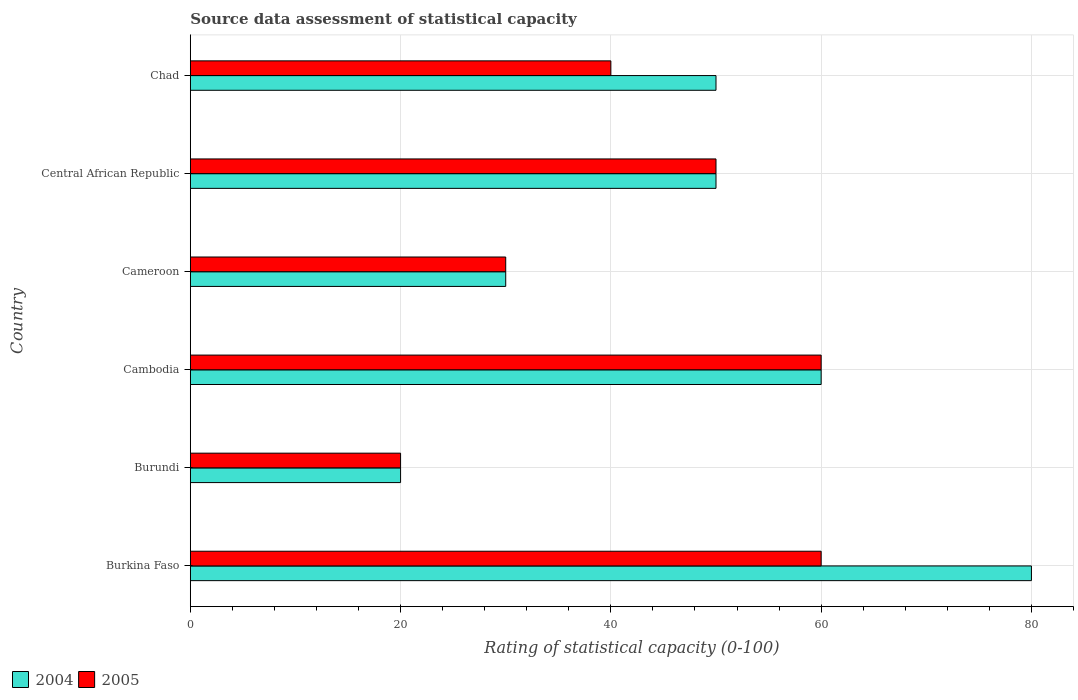How many groups of bars are there?
Your answer should be very brief. 6. Are the number of bars on each tick of the Y-axis equal?
Your answer should be compact. Yes. How many bars are there on the 2nd tick from the top?
Give a very brief answer. 2. How many bars are there on the 1st tick from the bottom?
Ensure brevity in your answer.  2. What is the label of the 3rd group of bars from the top?
Your answer should be very brief. Cameroon. In how many cases, is the number of bars for a given country not equal to the number of legend labels?
Keep it short and to the point. 0. What is the rating of statistical capacity in 2004 in Burkina Faso?
Keep it short and to the point. 80. Across all countries, what is the minimum rating of statistical capacity in 2005?
Offer a terse response. 20. In which country was the rating of statistical capacity in 2005 maximum?
Your answer should be very brief. Burkina Faso. In which country was the rating of statistical capacity in 2004 minimum?
Offer a very short reply. Burundi. What is the total rating of statistical capacity in 2005 in the graph?
Give a very brief answer. 260. What is the difference between the rating of statistical capacity in 2004 in Burkina Faso and that in Cambodia?
Provide a short and direct response. 20. What is the difference between the rating of statistical capacity in 2005 in Burundi and the rating of statistical capacity in 2004 in Burkina Faso?
Your answer should be compact. -60. What is the average rating of statistical capacity in 2004 per country?
Provide a short and direct response. 48.33. What is the difference between the rating of statistical capacity in 2004 and rating of statistical capacity in 2005 in Burkina Faso?
Provide a succinct answer. 20. In how many countries, is the rating of statistical capacity in 2005 greater than 40 ?
Provide a short and direct response. 3. What is the ratio of the rating of statistical capacity in 2005 in Burkina Faso to that in Cambodia?
Make the answer very short. 1. Is the rating of statistical capacity in 2004 in Burkina Faso less than that in Cameroon?
Give a very brief answer. No. Is the difference between the rating of statistical capacity in 2004 in Cameroon and Chad greater than the difference between the rating of statistical capacity in 2005 in Cameroon and Chad?
Your answer should be compact. No. What is the difference between the highest and the lowest rating of statistical capacity in 2005?
Your answer should be compact. 40. In how many countries, is the rating of statistical capacity in 2004 greater than the average rating of statistical capacity in 2004 taken over all countries?
Offer a terse response. 4. What does the 1st bar from the bottom in Chad represents?
Provide a short and direct response. 2004. How many countries are there in the graph?
Offer a terse response. 6. What is the difference between two consecutive major ticks on the X-axis?
Keep it short and to the point. 20. Are the values on the major ticks of X-axis written in scientific E-notation?
Offer a very short reply. No. Does the graph contain any zero values?
Offer a terse response. No. Does the graph contain grids?
Offer a very short reply. Yes. How are the legend labels stacked?
Keep it short and to the point. Horizontal. What is the title of the graph?
Your answer should be very brief. Source data assessment of statistical capacity. What is the label or title of the X-axis?
Ensure brevity in your answer.  Rating of statistical capacity (0-100). What is the Rating of statistical capacity (0-100) of 2004 in Burkina Faso?
Give a very brief answer. 80. What is the Rating of statistical capacity (0-100) of 2005 in Burkina Faso?
Your answer should be very brief. 60. What is the Rating of statistical capacity (0-100) in 2004 in Cameroon?
Provide a short and direct response. 30. What is the Rating of statistical capacity (0-100) of 2005 in Cameroon?
Provide a short and direct response. 30. What is the Rating of statistical capacity (0-100) of 2004 in Central African Republic?
Offer a very short reply. 50. What is the Rating of statistical capacity (0-100) of 2004 in Chad?
Give a very brief answer. 50. Across all countries, what is the maximum Rating of statistical capacity (0-100) in 2004?
Your answer should be very brief. 80. Across all countries, what is the minimum Rating of statistical capacity (0-100) in 2004?
Ensure brevity in your answer.  20. Across all countries, what is the minimum Rating of statistical capacity (0-100) of 2005?
Your answer should be compact. 20. What is the total Rating of statistical capacity (0-100) in 2004 in the graph?
Make the answer very short. 290. What is the total Rating of statistical capacity (0-100) of 2005 in the graph?
Provide a succinct answer. 260. What is the difference between the Rating of statistical capacity (0-100) in 2005 in Burkina Faso and that in Cameroon?
Offer a terse response. 30. What is the difference between the Rating of statistical capacity (0-100) of 2004 in Burkina Faso and that in Central African Republic?
Provide a succinct answer. 30. What is the difference between the Rating of statistical capacity (0-100) of 2005 in Burkina Faso and that in Central African Republic?
Give a very brief answer. 10. What is the difference between the Rating of statistical capacity (0-100) in 2004 in Burundi and that in Cameroon?
Provide a short and direct response. -10. What is the difference between the Rating of statistical capacity (0-100) of 2004 in Burundi and that in Chad?
Keep it short and to the point. -30. What is the difference between the Rating of statistical capacity (0-100) in 2004 in Cambodia and that in Central African Republic?
Your response must be concise. 10. What is the difference between the Rating of statistical capacity (0-100) in 2005 in Cambodia and that in Chad?
Ensure brevity in your answer.  20. What is the difference between the Rating of statistical capacity (0-100) of 2005 in Cameroon and that in Central African Republic?
Make the answer very short. -20. What is the difference between the Rating of statistical capacity (0-100) of 2004 in Central African Republic and that in Chad?
Give a very brief answer. 0. What is the difference between the Rating of statistical capacity (0-100) of 2005 in Central African Republic and that in Chad?
Your answer should be compact. 10. What is the difference between the Rating of statistical capacity (0-100) in 2004 in Burkina Faso and the Rating of statistical capacity (0-100) in 2005 in Cambodia?
Make the answer very short. 20. What is the difference between the Rating of statistical capacity (0-100) of 2004 in Burkina Faso and the Rating of statistical capacity (0-100) of 2005 in Cameroon?
Your response must be concise. 50. What is the difference between the Rating of statistical capacity (0-100) of 2004 in Burkina Faso and the Rating of statistical capacity (0-100) of 2005 in Chad?
Your answer should be compact. 40. What is the difference between the Rating of statistical capacity (0-100) in 2004 in Burundi and the Rating of statistical capacity (0-100) in 2005 in Chad?
Offer a very short reply. -20. What is the difference between the Rating of statistical capacity (0-100) in 2004 in Cambodia and the Rating of statistical capacity (0-100) in 2005 in Central African Republic?
Your answer should be compact. 10. What is the difference between the Rating of statistical capacity (0-100) of 2004 in Cameroon and the Rating of statistical capacity (0-100) of 2005 in Central African Republic?
Your response must be concise. -20. What is the difference between the Rating of statistical capacity (0-100) in 2004 in Central African Republic and the Rating of statistical capacity (0-100) in 2005 in Chad?
Make the answer very short. 10. What is the average Rating of statistical capacity (0-100) of 2004 per country?
Your answer should be very brief. 48.33. What is the average Rating of statistical capacity (0-100) of 2005 per country?
Offer a terse response. 43.33. What is the difference between the Rating of statistical capacity (0-100) of 2004 and Rating of statistical capacity (0-100) of 2005 in Burkina Faso?
Provide a short and direct response. 20. What is the difference between the Rating of statistical capacity (0-100) in 2004 and Rating of statistical capacity (0-100) in 2005 in Cameroon?
Offer a terse response. 0. What is the difference between the Rating of statistical capacity (0-100) of 2004 and Rating of statistical capacity (0-100) of 2005 in Chad?
Your answer should be very brief. 10. What is the ratio of the Rating of statistical capacity (0-100) of 2004 in Burkina Faso to that in Burundi?
Your answer should be compact. 4. What is the ratio of the Rating of statistical capacity (0-100) of 2005 in Burkina Faso to that in Burundi?
Provide a short and direct response. 3. What is the ratio of the Rating of statistical capacity (0-100) in 2004 in Burkina Faso to that in Cambodia?
Make the answer very short. 1.33. What is the ratio of the Rating of statistical capacity (0-100) in 2004 in Burkina Faso to that in Cameroon?
Ensure brevity in your answer.  2.67. What is the ratio of the Rating of statistical capacity (0-100) of 2005 in Burkina Faso to that in Chad?
Make the answer very short. 1.5. What is the ratio of the Rating of statistical capacity (0-100) in 2004 in Burundi to that in Cameroon?
Provide a short and direct response. 0.67. What is the ratio of the Rating of statistical capacity (0-100) in 2004 in Burundi to that in Central African Republic?
Provide a short and direct response. 0.4. What is the ratio of the Rating of statistical capacity (0-100) of 2005 in Burundi to that in Chad?
Make the answer very short. 0.5. What is the ratio of the Rating of statistical capacity (0-100) in 2004 in Cambodia to that in Cameroon?
Ensure brevity in your answer.  2. What is the ratio of the Rating of statistical capacity (0-100) of 2005 in Cambodia to that in Cameroon?
Keep it short and to the point. 2. What is the ratio of the Rating of statistical capacity (0-100) in 2004 in Cambodia to that in Chad?
Your answer should be very brief. 1.2. What is the ratio of the Rating of statistical capacity (0-100) in 2005 in Cambodia to that in Chad?
Your answer should be compact. 1.5. What is the ratio of the Rating of statistical capacity (0-100) of 2005 in Cameroon to that in Central African Republic?
Give a very brief answer. 0.6. What is the ratio of the Rating of statistical capacity (0-100) of 2004 in Cameroon to that in Chad?
Your answer should be very brief. 0.6. What is the ratio of the Rating of statistical capacity (0-100) in 2005 in Cameroon to that in Chad?
Make the answer very short. 0.75. What is the ratio of the Rating of statistical capacity (0-100) in 2004 in Central African Republic to that in Chad?
Provide a succinct answer. 1. What is the ratio of the Rating of statistical capacity (0-100) of 2005 in Central African Republic to that in Chad?
Give a very brief answer. 1.25. What is the difference between the highest and the lowest Rating of statistical capacity (0-100) of 2005?
Your answer should be compact. 40. 